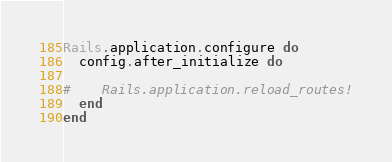<code> <loc_0><loc_0><loc_500><loc_500><_Ruby_>
Rails.application.configure do
  config.after_initialize do

#    Rails.application.reload_routes!
  end
end
</code> 